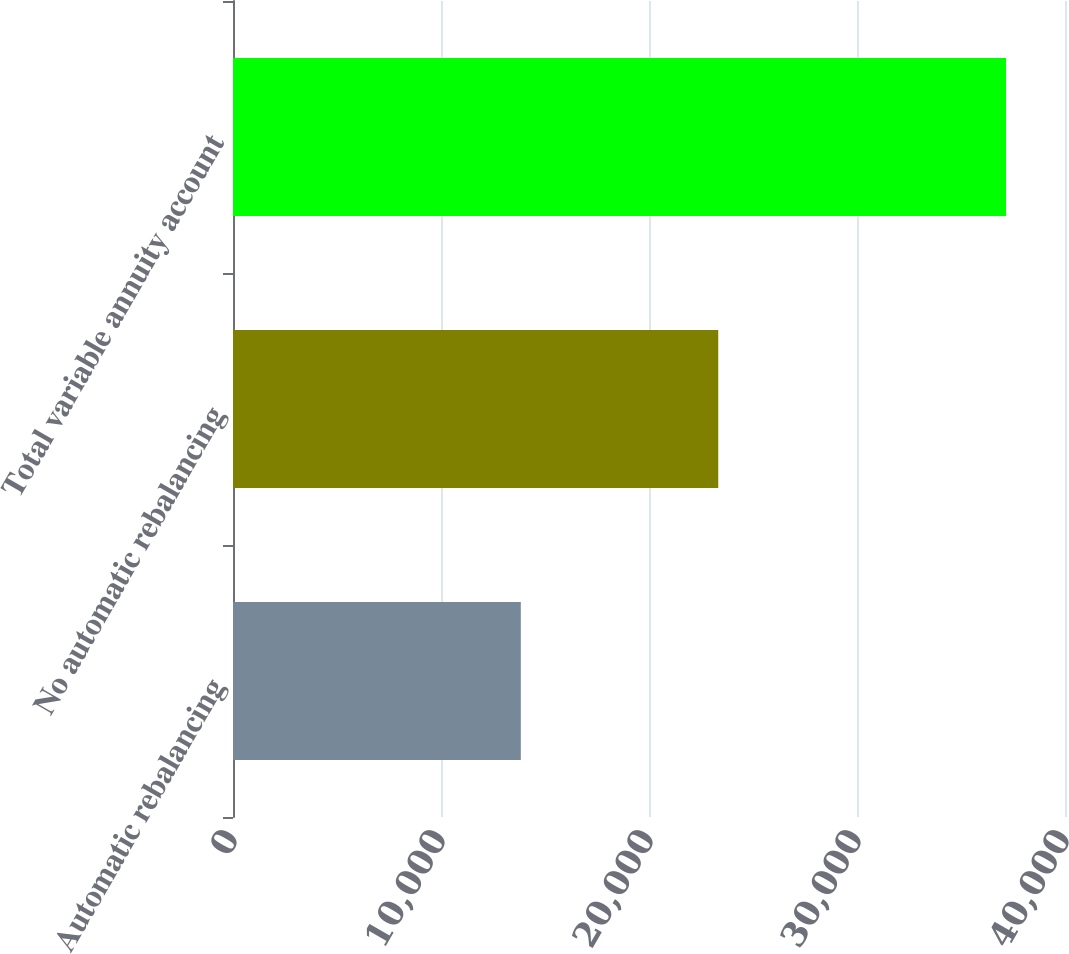Convert chart to OTSL. <chart><loc_0><loc_0><loc_500><loc_500><bar_chart><fcel>Automatic rebalancing<fcel>No automatic rebalancing<fcel>Total variable annuity account<nl><fcel>13837<fcel>23329<fcel>37166<nl></chart> 